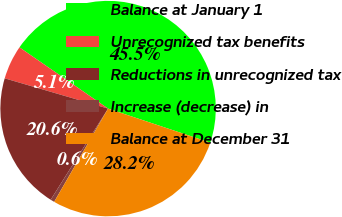Convert chart to OTSL. <chart><loc_0><loc_0><loc_500><loc_500><pie_chart><fcel>Balance at January 1<fcel>Unrecognized tax benefits<fcel>Reductions in unrecognized tax<fcel>Increase (decrease) in<fcel>Balance at December 31<nl><fcel>45.5%<fcel>5.09%<fcel>20.59%<fcel>0.6%<fcel>28.22%<nl></chart> 